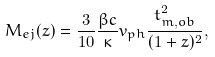Convert formula to latex. <formula><loc_0><loc_0><loc_500><loc_500>M _ { e j } ( z ) = \frac { 3 } { 1 0 } \frac { \beta c } { \kappa } v _ { p h } \frac { t _ { m , o b } ^ { 2 } } { ( 1 + z ) ^ { 2 } } ,</formula> 